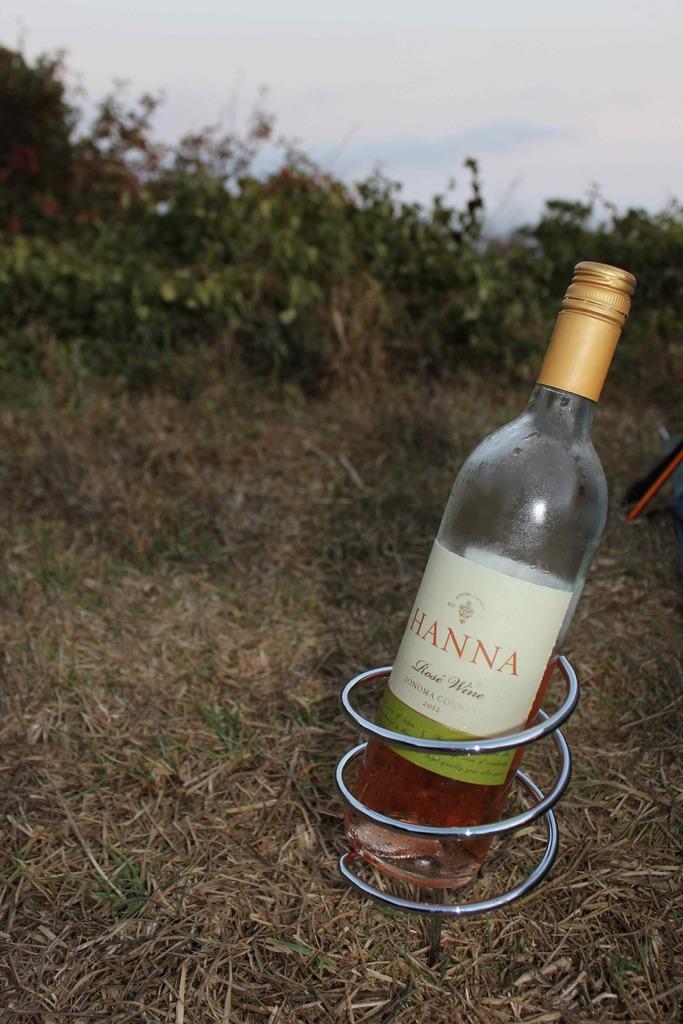What kind of wine is in the bottle?
Keep it short and to the point. Hanna. 